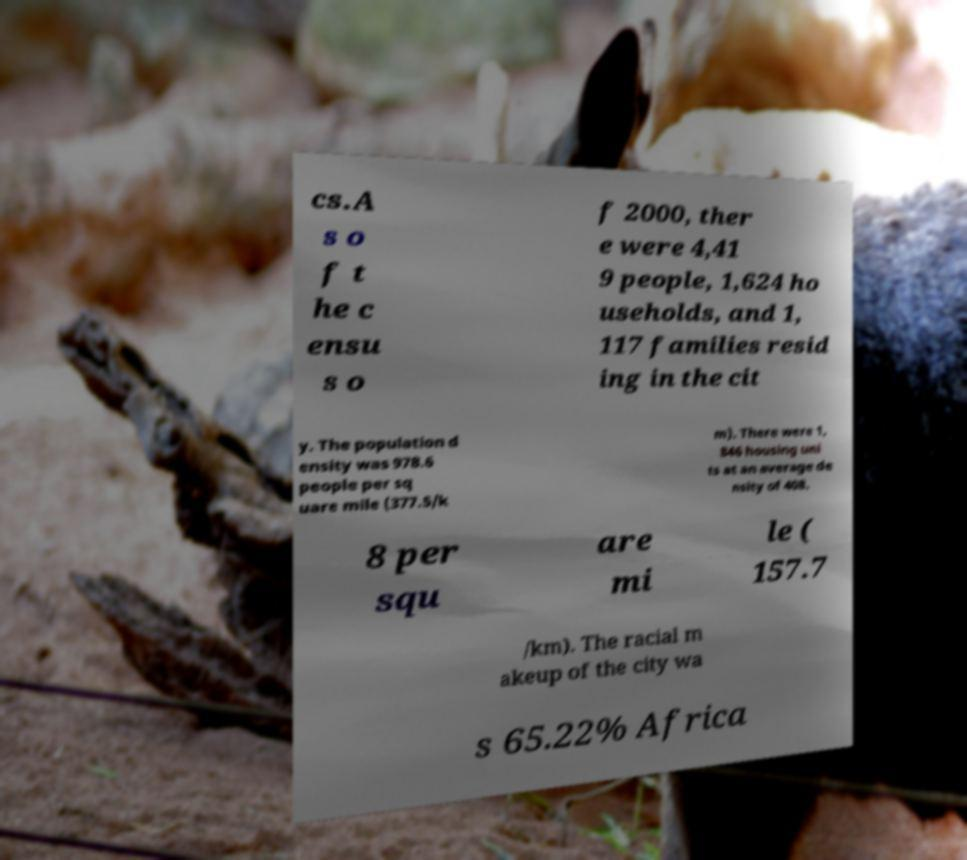Please identify and transcribe the text found in this image. cs.A s o f t he c ensu s o f 2000, ther e were 4,41 9 people, 1,624 ho useholds, and 1, 117 families resid ing in the cit y. The population d ensity was 978.6 people per sq uare mile (377.5/k m). There were 1, 846 housing uni ts at an average de nsity of 408. 8 per squ are mi le ( 157.7 /km). The racial m akeup of the city wa s 65.22% Africa 